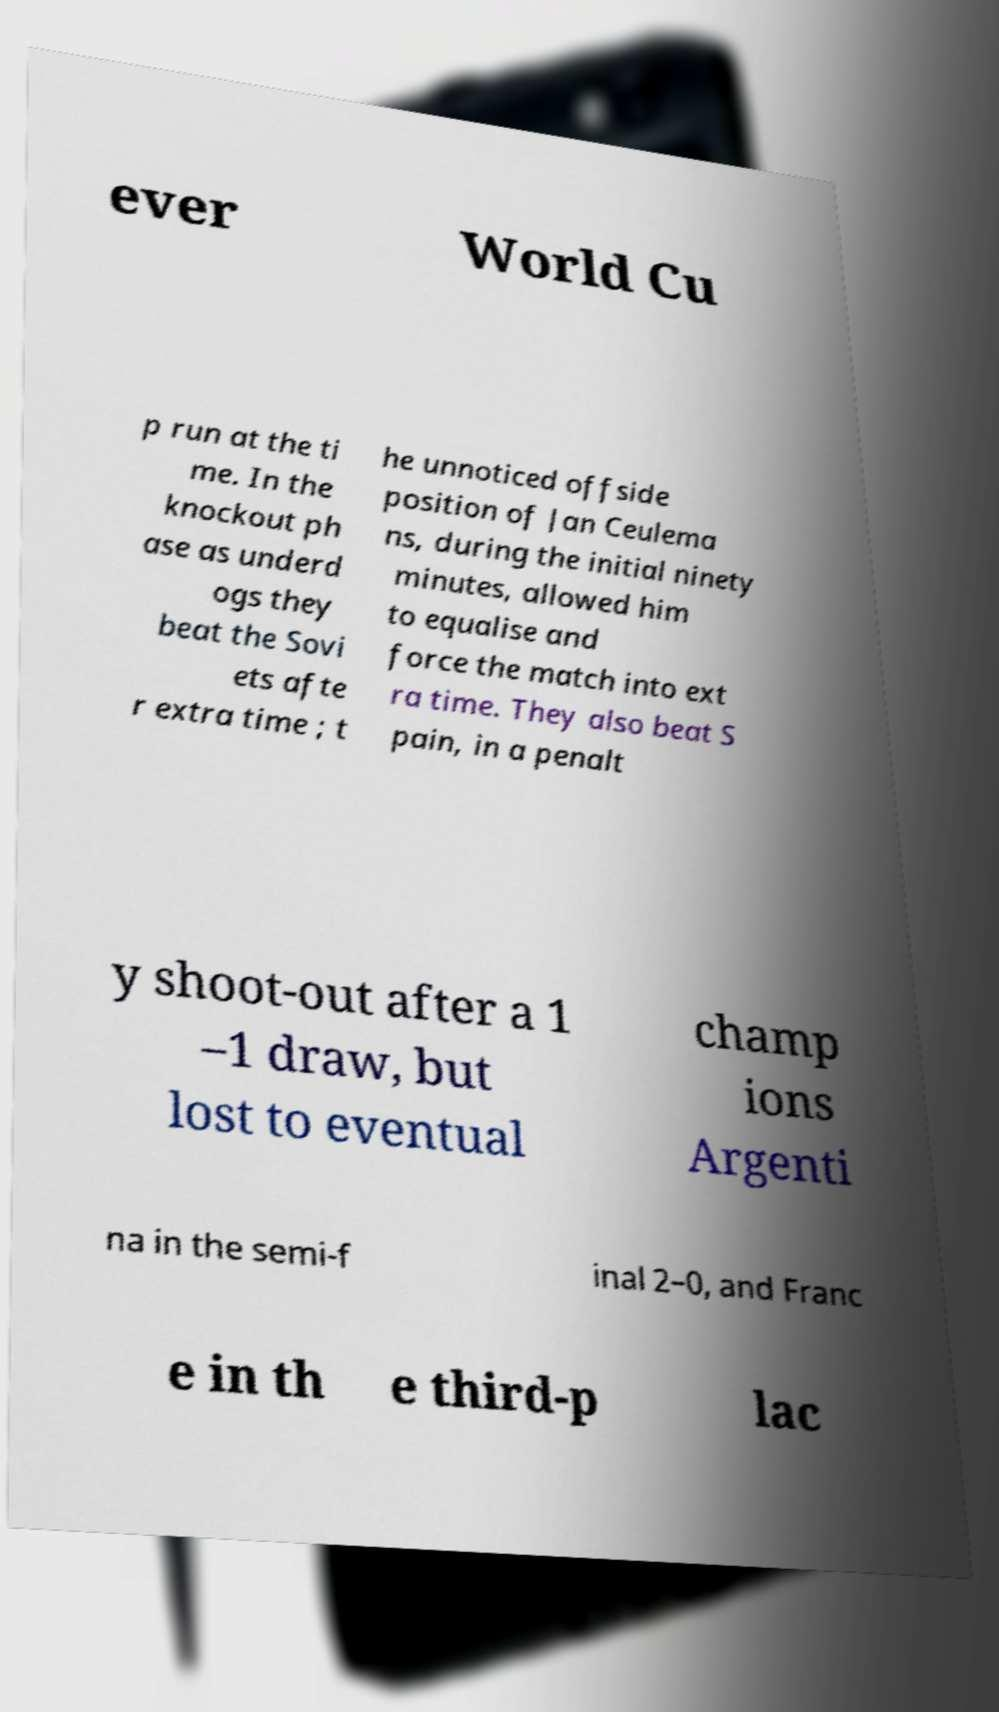Can you accurately transcribe the text from the provided image for me? ever World Cu p run at the ti me. In the knockout ph ase as underd ogs they beat the Sovi ets afte r extra time ; t he unnoticed offside position of Jan Ceulema ns, during the initial ninety minutes, allowed him to equalise and force the match into ext ra time. They also beat S pain, in a penalt y shoot-out after a 1 –1 draw, but lost to eventual champ ions Argenti na in the semi-f inal 2–0, and Franc e in th e third-p lac 